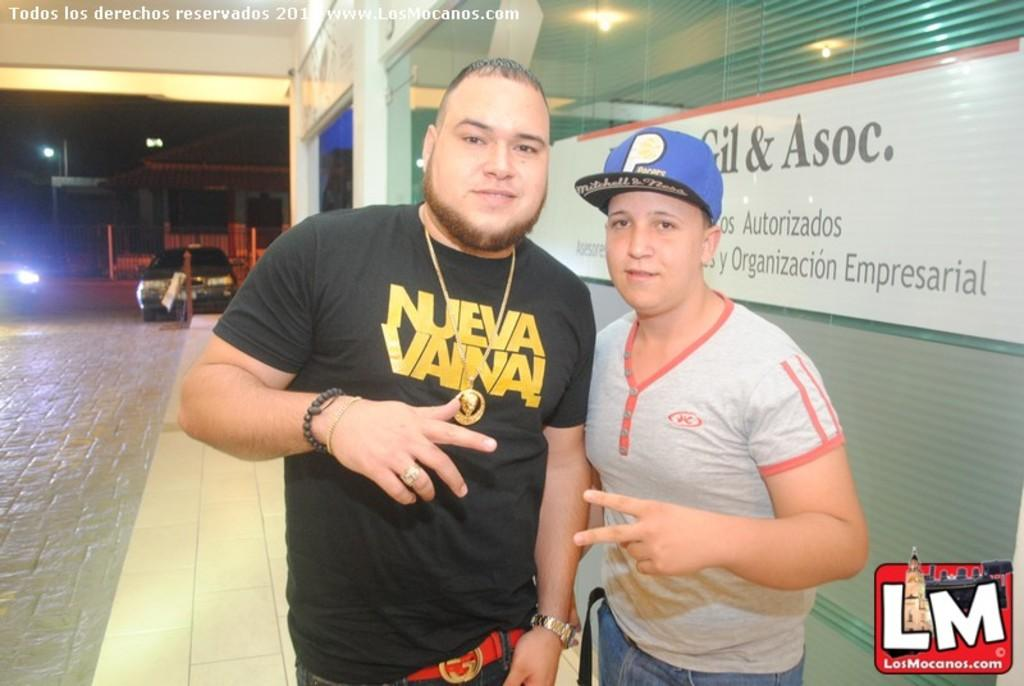Who are the main subjects in the image? There are two men in the center of the image. What can be seen on the left side of the image? There are cars on the left side of the image. What is located on the right side of the image? There is a glass door on the right side of the image. What type of slave is depicted in the image? There is no slave depicted in the image; it features two men and cars. What type of airplane can be seen flying in the image? There is no airplane present in the image. 